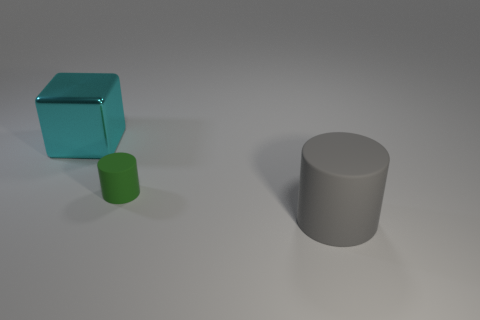What is the big object that is behind the small thing made of?
Provide a short and direct response. Metal. How many blue objects are either big cylinders or big shiny things?
Keep it short and to the point. 0. Is the material of the small cylinder the same as the big thing on the right side of the metallic thing?
Ensure brevity in your answer.  Yes. Are there an equal number of large gray matte things that are on the left side of the big cylinder and gray cylinders behind the green thing?
Offer a very short reply. Yes. There is a cube; does it have the same size as the matte object to the right of the tiny green object?
Provide a short and direct response. Yes. Are there more cyan things that are in front of the big gray thing than rubber objects?
Provide a short and direct response. No. How many rubber objects have the same size as the cyan cube?
Your response must be concise. 1. There is a cylinder in front of the small matte thing; does it have the same size as the rubber object left of the large matte thing?
Ensure brevity in your answer.  No. Is the number of things behind the tiny cylinder greater than the number of matte cylinders on the left side of the shiny cube?
Your response must be concise. Yes. How many other small rubber objects are the same shape as the green object?
Provide a succinct answer. 0. 